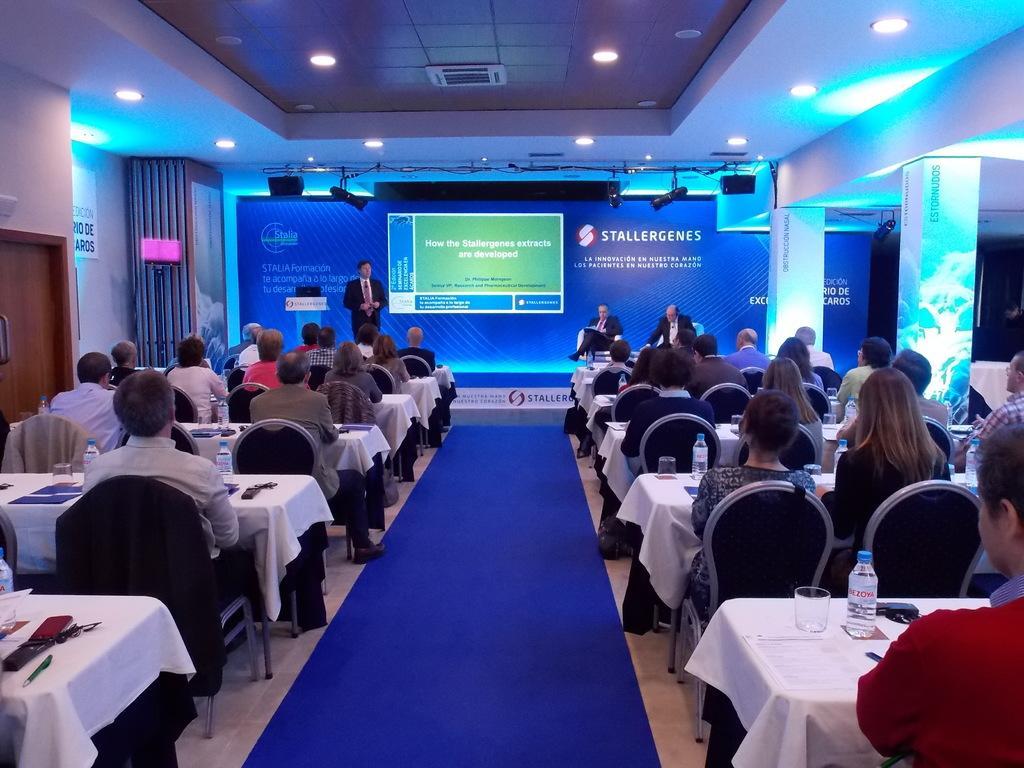Could you give a brief overview of what you see in this image? At the bottom of the image on the floor there is a blue carpet. On the sides of the carper there are table with mobiles, glasses, bottles and some other things. There are few people sitting on the chairs. In front of them there is a stage with two men are sitting and there is a man standing. Beside the man there is a podium. Behind them there is a screen with something written on it. Beside the stage on the left side there is a banner and also there is a lamp. And on the right side of the image there are pillars with lights. At the top of the image there is ceiling with lights. And on the left corner of the image there is a wall with a door. 